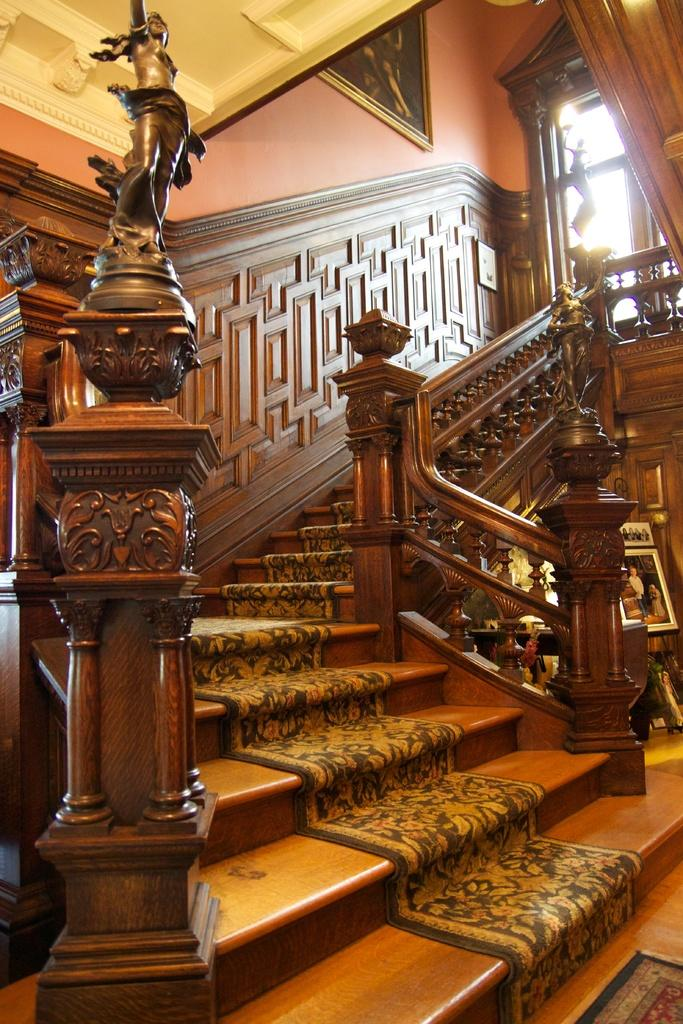What type of location is depicted in the image? The image is an inside picture of a building. What architectural feature can be seen in the image? There are stairs in the image. What type of decorative objects are present in the image? There are statues and photo frames in the image. What can be seen through the window in the image? The wall is visible in the image. What type of fan is visible in the image? There is no fan present in the image. What achievements are the statues in the image celebrating? The statues in the image do not represent specific achievements; they are decorative objects. 